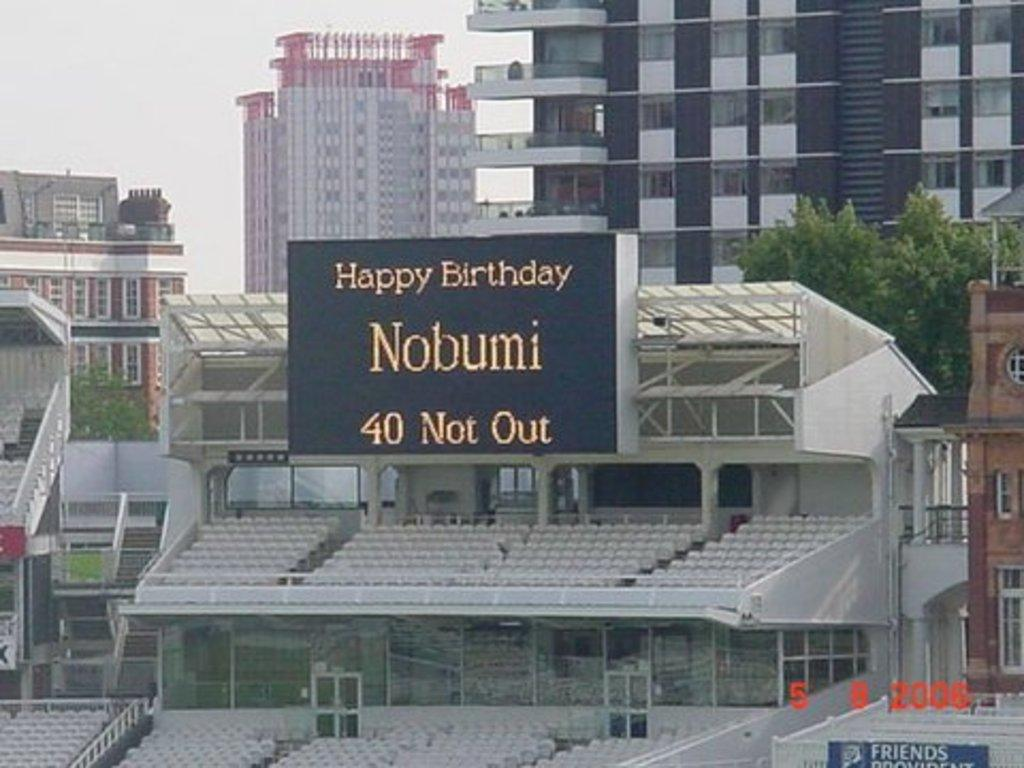<image>
Describe the image concisely. A large sign at an outside stadium says "Happy Birthday Nobumi, 40 Not Out". 